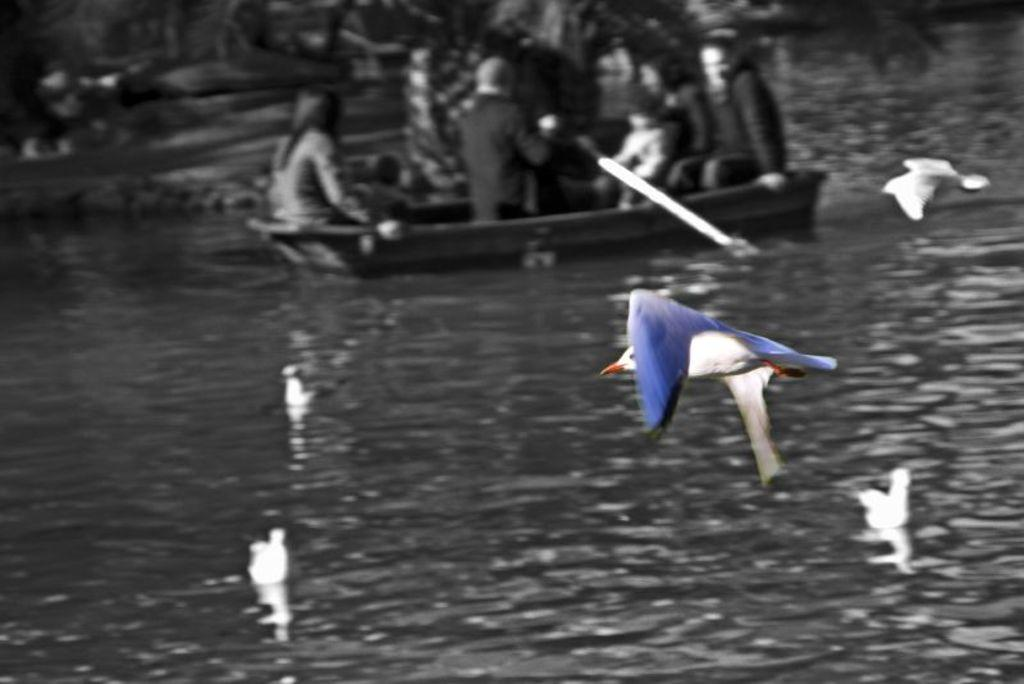What type of animals can be seen in the image? There are birds in the image. What is the primary element in which the birds are situated? The birds are situated in water. What is on the water in the image? There is a boat on the water. Who or what is in the boat? People are sitting in the boat. What word is being used by the daughter in the image? There is no daughter present in the image, so it is not possible to determine what word she might be using. 